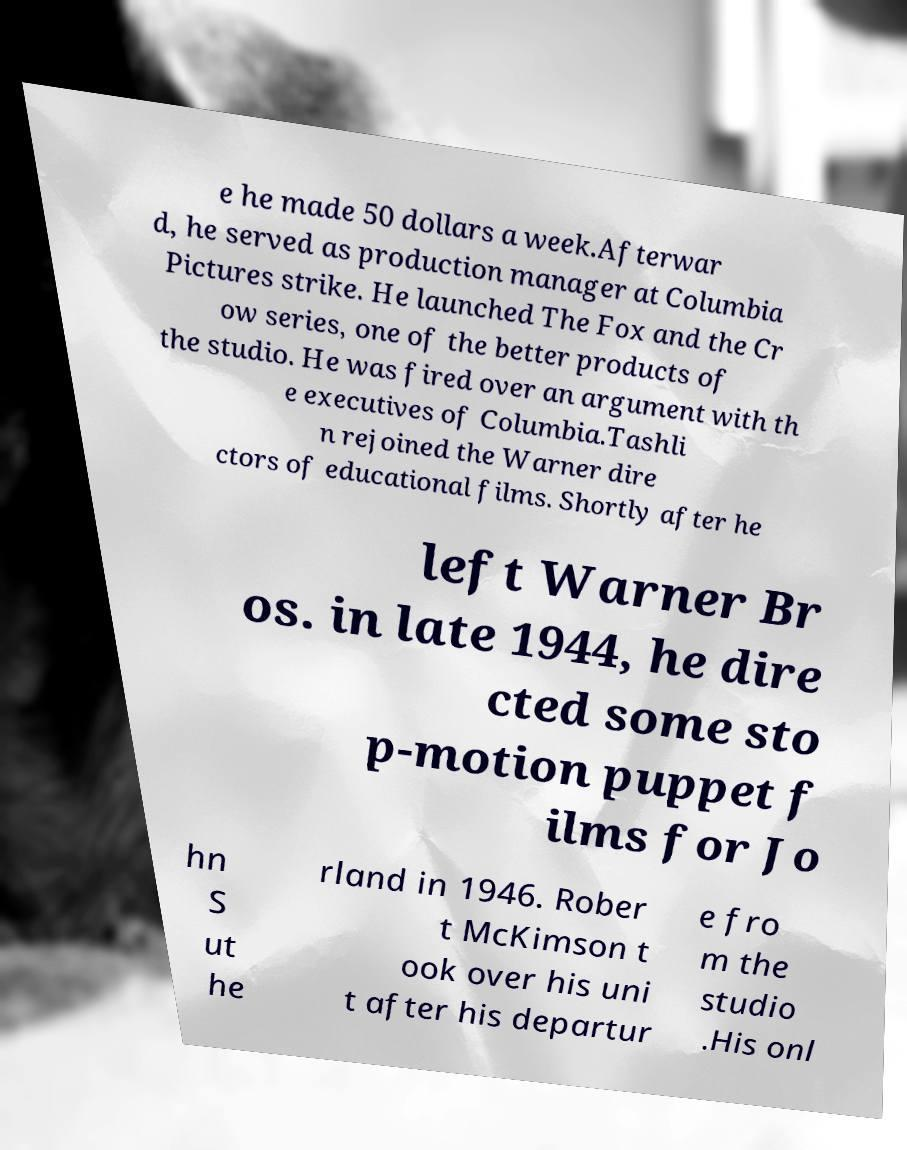Can you read and provide the text displayed in the image?This photo seems to have some interesting text. Can you extract and type it out for me? e he made 50 dollars a week.Afterwar d, he served as production manager at Columbia Pictures strike. He launched The Fox and the Cr ow series, one of the better products of the studio. He was fired over an argument with th e executives of Columbia.Tashli n rejoined the Warner dire ctors of educational films. Shortly after he left Warner Br os. in late 1944, he dire cted some sto p-motion puppet f ilms for Jo hn S ut he rland in 1946. Rober t McKimson t ook over his uni t after his departur e fro m the studio .His onl 